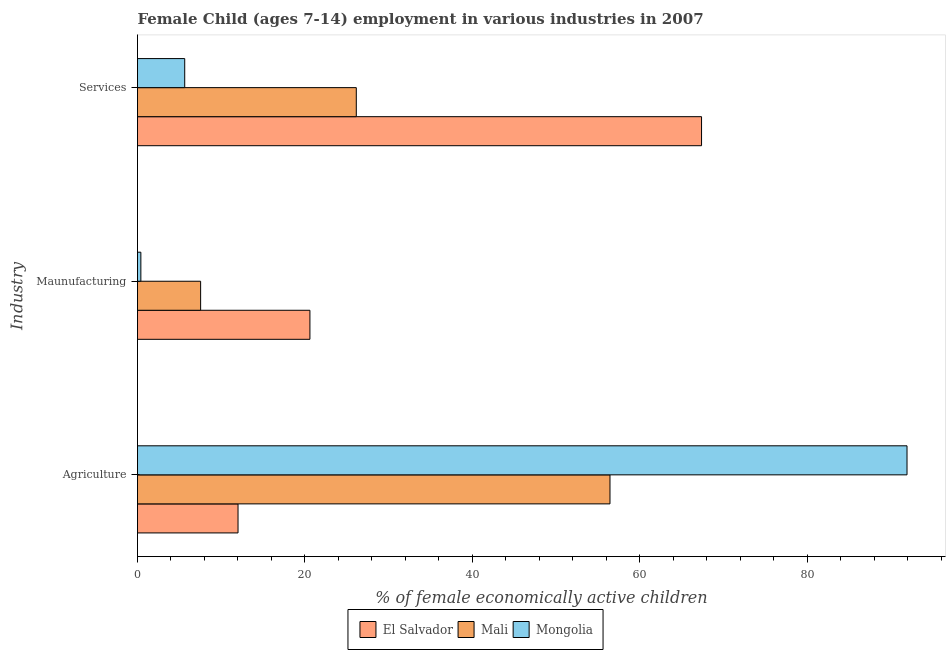How many groups of bars are there?
Your answer should be compact. 3. Are the number of bars per tick equal to the number of legend labels?
Ensure brevity in your answer.  Yes. Are the number of bars on each tick of the Y-axis equal?
Provide a succinct answer. Yes. How many bars are there on the 2nd tick from the bottom?
Your response must be concise. 3. What is the label of the 1st group of bars from the top?
Provide a succinct answer. Services. What is the percentage of economically active children in agriculture in Mali?
Provide a succinct answer. 56.45. Across all countries, what is the maximum percentage of economically active children in manufacturing?
Provide a succinct answer. 20.6. Across all countries, what is the minimum percentage of economically active children in services?
Give a very brief answer. 5.64. In which country was the percentage of economically active children in agriculture maximum?
Your response must be concise. Mongolia. In which country was the percentage of economically active children in manufacturing minimum?
Provide a succinct answer. Mongolia. What is the total percentage of economically active children in manufacturing in the graph?
Offer a terse response. 28.54. What is the difference between the percentage of economically active children in services in El Salvador and that in Mali?
Your answer should be very brief. 41.25. What is the difference between the percentage of economically active children in services in El Salvador and the percentage of economically active children in manufacturing in Mongolia?
Your response must be concise. 66.99. What is the average percentage of economically active children in services per country?
Provide a succinct answer. 33.06. What is the difference between the percentage of economically active children in agriculture and percentage of economically active children in services in El Salvador?
Your answer should be very brief. -55.38. What is the ratio of the percentage of economically active children in services in El Salvador to that in Mali?
Your answer should be compact. 2.58. Is the percentage of economically active children in services in Mongolia less than that in Mali?
Offer a very short reply. Yes. What is the difference between the highest and the second highest percentage of economically active children in agriculture?
Provide a short and direct response. 35.49. What is the difference between the highest and the lowest percentage of economically active children in agriculture?
Ensure brevity in your answer.  79.93. Is the sum of the percentage of economically active children in manufacturing in Mongolia and El Salvador greater than the maximum percentage of economically active children in agriculture across all countries?
Give a very brief answer. No. What does the 1st bar from the top in Agriculture represents?
Make the answer very short. Mongolia. What does the 1st bar from the bottom in Maunufacturing represents?
Keep it short and to the point. El Salvador. Is it the case that in every country, the sum of the percentage of economically active children in agriculture and percentage of economically active children in manufacturing is greater than the percentage of economically active children in services?
Offer a terse response. No. How many bars are there?
Offer a terse response. 9. What is the difference between two consecutive major ticks on the X-axis?
Your answer should be compact. 20. Does the graph contain grids?
Keep it short and to the point. No. How are the legend labels stacked?
Make the answer very short. Horizontal. What is the title of the graph?
Provide a succinct answer. Female Child (ages 7-14) employment in various industries in 2007. What is the label or title of the X-axis?
Provide a succinct answer. % of female economically active children. What is the label or title of the Y-axis?
Provide a succinct answer. Industry. What is the % of female economically active children in El Salvador in Agriculture?
Your answer should be compact. 12.01. What is the % of female economically active children of Mali in Agriculture?
Offer a terse response. 56.45. What is the % of female economically active children in Mongolia in Agriculture?
Provide a succinct answer. 91.94. What is the % of female economically active children in El Salvador in Maunufacturing?
Ensure brevity in your answer.  20.6. What is the % of female economically active children of Mali in Maunufacturing?
Keep it short and to the point. 7.54. What is the % of female economically active children of El Salvador in Services?
Offer a terse response. 67.39. What is the % of female economically active children in Mali in Services?
Your response must be concise. 26.14. What is the % of female economically active children in Mongolia in Services?
Offer a very short reply. 5.64. Across all Industry, what is the maximum % of female economically active children in El Salvador?
Provide a succinct answer. 67.39. Across all Industry, what is the maximum % of female economically active children of Mali?
Make the answer very short. 56.45. Across all Industry, what is the maximum % of female economically active children in Mongolia?
Ensure brevity in your answer.  91.94. Across all Industry, what is the minimum % of female economically active children in El Salvador?
Offer a terse response. 12.01. Across all Industry, what is the minimum % of female economically active children in Mali?
Your response must be concise. 7.54. What is the total % of female economically active children in Mali in the graph?
Keep it short and to the point. 90.13. What is the total % of female economically active children of Mongolia in the graph?
Ensure brevity in your answer.  97.98. What is the difference between the % of female economically active children in El Salvador in Agriculture and that in Maunufacturing?
Your answer should be very brief. -8.59. What is the difference between the % of female economically active children in Mali in Agriculture and that in Maunufacturing?
Your response must be concise. 48.91. What is the difference between the % of female economically active children of Mongolia in Agriculture and that in Maunufacturing?
Your response must be concise. 91.54. What is the difference between the % of female economically active children in El Salvador in Agriculture and that in Services?
Keep it short and to the point. -55.38. What is the difference between the % of female economically active children of Mali in Agriculture and that in Services?
Offer a terse response. 30.31. What is the difference between the % of female economically active children in Mongolia in Agriculture and that in Services?
Keep it short and to the point. 86.3. What is the difference between the % of female economically active children of El Salvador in Maunufacturing and that in Services?
Give a very brief answer. -46.79. What is the difference between the % of female economically active children of Mali in Maunufacturing and that in Services?
Give a very brief answer. -18.6. What is the difference between the % of female economically active children in Mongolia in Maunufacturing and that in Services?
Ensure brevity in your answer.  -5.24. What is the difference between the % of female economically active children of El Salvador in Agriculture and the % of female economically active children of Mali in Maunufacturing?
Offer a very short reply. 4.47. What is the difference between the % of female economically active children in El Salvador in Agriculture and the % of female economically active children in Mongolia in Maunufacturing?
Give a very brief answer. 11.61. What is the difference between the % of female economically active children in Mali in Agriculture and the % of female economically active children in Mongolia in Maunufacturing?
Give a very brief answer. 56.05. What is the difference between the % of female economically active children in El Salvador in Agriculture and the % of female economically active children in Mali in Services?
Offer a very short reply. -14.13. What is the difference between the % of female economically active children of El Salvador in Agriculture and the % of female economically active children of Mongolia in Services?
Offer a very short reply. 6.37. What is the difference between the % of female economically active children of Mali in Agriculture and the % of female economically active children of Mongolia in Services?
Provide a succinct answer. 50.81. What is the difference between the % of female economically active children of El Salvador in Maunufacturing and the % of female economically active children of Mali in Services?
Provide a short and direct response. -5.54. What is the difference between the % of female economically active children of El Salvador in Maunufacturing and the % of female economically active children of Mongolia in Services?
Offer a very short reply. 14.96. What is the difference between the % of female economically active children in Mali in Maunufacturing and the % of female economically active children in Mongolia in Services?
Your answer should be compact. 1.9. What is the average % of female economically active children in El Salvador per Industry?
Offer a terse response. 33.33. What is the average % of female economically active children in Mali per Industry?
Your response must be concise. 30.04. What is the average % of female economically active children of Mongolia per Industry?
Your answer should be compact. 32.66. What is the difference between the % of female economically active children of El Salvador and % of female economically active children of Mali in Agriculture?
Your response must be concise. -44.44. What is the difference between the % of female economically active children of El Salvador and % of female economically active children of Mongolia in Agriculture?
Provide a short and direct response. -79.93. What is the difference between the % of female economically active children of Mali and % of female economically active children of Mongolia in Agriculture?
Provide a succinct answer. -35.49. What is the difference between the % of female economically active children of El Salvador and % of female economically active children of Mali in Maunufacturing?
Provide a succinct answer. 13.06. What is the difference between the % of female economically active children in El Salvador and % of female economically active children in Mongolia in Maunufacturing?
Your answer should be compact. 20.2. What is the difference between the % of female economically active children of Mali and % of female economically active children of Mongolia in Maunufacturing?
Ensure brevity in your answer.  7.14. What is the difference between the % of female economically active children of El Salvador and % of female economically active children of Mali in Services?
Offer a terse response. 41.25. What is the difference between the % of female economically active children in El Salvador and % of female economically active children in Mongolia in Services?
Keep it short and to the point. 61.75. What is the difference between the % of female economically active children of Mali and % of female economically active children of Mongolia in Services?
Your response must be concise. 20.5. What is the ratio of the % of female economically active children in El Salvador in Agriculture to that in Maunufacturing?
Ensure brevity in your answer.  0.58. What is the ratio of the % of female economically active children in Mali in Agriculture to that in Maunufacturing?
Make the answer very short. 7.49. What is the ratio of the % of female economically active children of Mongolia in Agriculture to that in Maunufacturing?
Provide a short and direct response. 229.85. What is the ratio of the % of female economically active children in El Salvador in Agriculture to that in Services?
Ensure brevity in your answer.  0.18. What is the ratio of the % of female economically active children of Mali in Agriculture to that in Services?
Keep it short and to the point. 2.16. What is the ratio of the % of female economically active children of Mongolia in Agriculture to that in Services?
Your answer should be very brief. 16.3. What is the ratio of the % of female economically active children in El Salvador in Maunufacturing to that in Services?
Offer a terse response. 0.31. What is the ratio of the % of female economically active children of Mali in Maunufacturing to that in Services?
Offer a terse response. 0.29. What is the ratio of the % of female economically active children of Mongolia in Maunufacturing to that in Services?
Your answer should be very brief. 0.07. What is the difference between the highest and the second highest % of female economically active children of El Salvador?
Offer a very short reply. 46.79. What is the difference between the highest and the second highest % of female economically active children in Mali?
Make the answer very short. 30.31. What is the difference between the highest and the second highest % of female economically active children of Mongolia?
Your answer should be compact. 86.3. What is the difference between the highest and the lowest % of female economically active children of El Salvador?
Provide a succinct answer. 55.38. What is the difference between the highest and the lowest % of female economically active children in Mali?
Offer a very short reply. 48.91. What is the difference between the highest and the lowest % of female economically active children in Mongolia?
Provide a short and direct response. 91.54. 